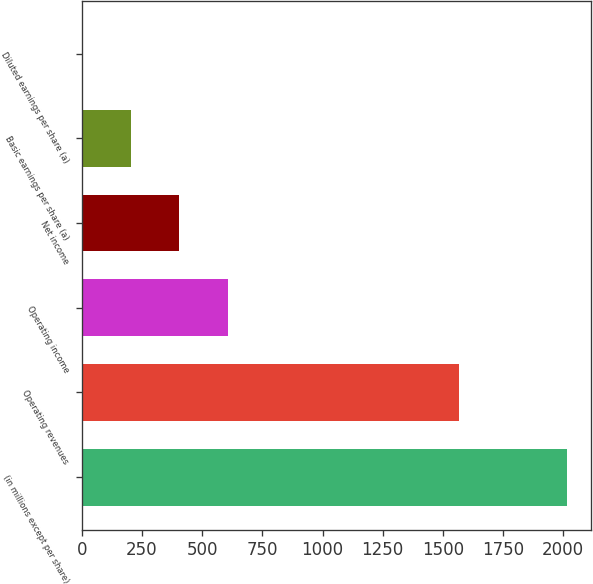Convert chart to OTSL. <chart><loc_0><loc_0><loc_500><loc_500><bar_chart><fcel>(in millions except per share)<fcel>Operating revenues<fcel>Operating income<fcel>Net income<fcel>Basic earnings per share (a)<fcel>Diluted earnings per share (a)<nl><fcel>2016<fcel>1566<fcel>606.24<fcel>404.85<fcel>203.46<fcel>2.07<nl></chart> 